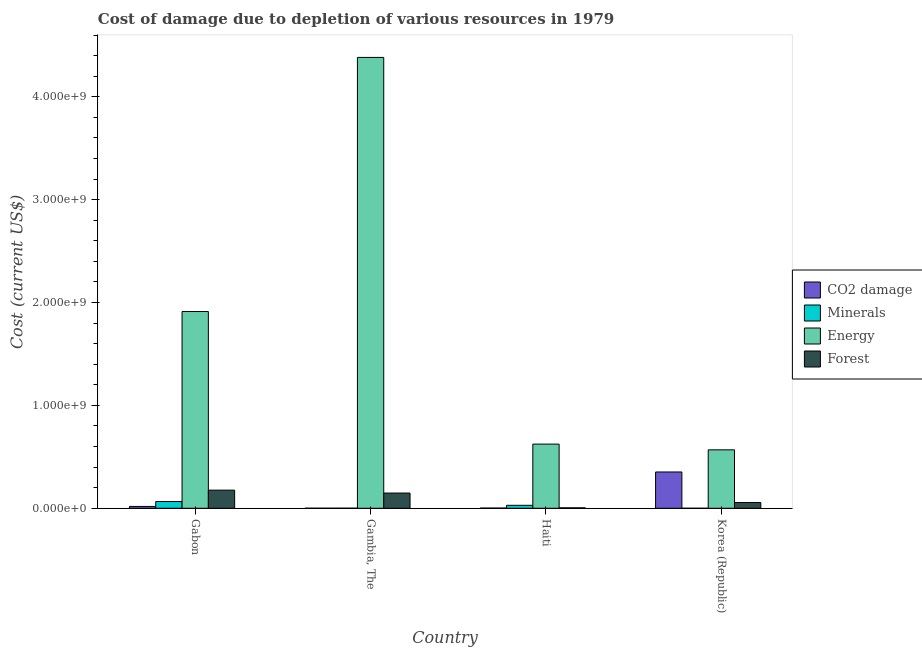How many groups of bars are there?
Your answer should be compact. 4. Are the number of bars per tick equal to the number of legend labels?
Offer a terse response. Yes. Are the number of bars on each tick of the X-axis equal?
Offer a terse response. Yes. How many bars are there on the 1st tick from the left?
Offer a very short reply. 4. How many bars are there on the 3rd tick from the right?
Provide a short and direct response. 4. What is the label of the 3rd group of bars from the left?
Give a very brief answer. Haiti. In how many cases, is the number of bars for a given country not equal to the number of legend labels?
Keep it short and to the point. 0. What is the cost of damage due to depletion of coal in Haiti?
Keep it short and to the point. 2.00e+06. Across all countries, what is the maximum cost of damage due to depletion of energy?
Your answer should be compact. 4.38e+09. Across all countries, what is the minimum cost of damage due to depletion of coal?
Give a very brief answer. 3.89e+05. In which country was the cost of damage due to depletion of coal maximum?
Give a very brief answer. Korea (Republic). In which country was the cost of damage due to depletion of forests minimum?
Provide a short and direct response. Haiti. What is the total cost of damage due to depletion of energy in the graph?
Provide a short and direct response. 7.49e+09. What is the difference between the cost of damage due to depletion of energy in Haiti and that in Korea (Republic)?
Provide a short and direct response. 5.58e+07. What is the difference between the cost of damage due to depletion of energy in Korea (Republic) and the cost of damage due to depletion of minerals in Gabon?
Give a very brief answer. 5.02e+08. What is the average cost of damage due to depletion of coal per country?
Ensure brevity in your answer.  9.33e+07. What is the difference between the cost of damage due to depletion of forests and cost of damage due to depletion of minerals in Gabon?
Offer a very short reply. 1.11e+08. In how many countries, is the cost of damage due to depletion of forests greater than 1600000000 US$?
Your response must be concise. 0. What is the ratio of the cost of damage due to depletion of minerals in Gabon to that in Gambia, The?
Provide a short and direct response. 117.33. Is the cost of damage due to depletion of minerals in Gabon less than that in Gambia, The?
Your response must be concise. No. Is the difference between the cost of damage due to depletion of forests in Gabon and Korea (Republic) greater than the difference between the cost of damage due to depletion of energy in Gabon and Korea (Republic)?
Provide a short and direct response. No. What is the difference between the highest and the second highest cost of damage due to depletion of coal?
Your answer should be very brief. 3.35e+08. What is the difference between the highest and the lowest cost of damage due to depletion of energy?
Provide a succinct answer. 3.81e+09. Is the sum of the cost of damage due to depletion of forests in Gabon and Haiti greater than the maximum cost of damage due to depletion of minerals across all countries?
Offer a very short reply. Yes. What does the 3rd bar from the left in Gabon represents?
Offer a very short reply. Energy. What does the 1st bar from the right in Haiti represents?
Your answer should be compact. Forest. Is it the case that in every country, the sum of the cost of damage due to depletion of coal and cost of damage due to depletion of minerals is greater than the cost of damage due to depletion of energy?
Your answer should be compact. No. What is the difference between two consecutive major ticks on the Y-axis?
Your response must be concise. 1.00e+09. Are the values on the major ticks of Y-axis written in scientific E-notation?
Make the answer very short. Yes. Where does the legend appear in the graph?
Give a very brief answer. Center right. How many legend labels are there?
Your answer should be compact. 4. What is the title of the graph?
Provide a short and direct response. Cost of damage due to depletion of various resources in 1979 . Does "Agriculture" appear as one of the legend labels in the graph?
Keep it short and to the point. No. What is the label or title of the Y-axis?
Keep it short and to the point. Cost (current US$). What is the Cost (current US$) in CO2 damage in Gabon?
Keep it short and to the point. 1.79e+07. What is the Cost (current US$) of Minerals in Gabon?
Ensure brevity in your answer.  6.56e+07. What is the Cost (current US$) of Energy in Gabon?
Offer a very short reply. 1.91e+09. What is the Cost (current US$) of Forest in Gabon?
Keep it short and to the point. 1.76e+08. What is the Cost (current US$) of CO2 damage in Gambia, The?
Make the answer very short. 3.89e+05. What is the Cost (current US$) of Minerals in Gambia, The?
Give a very brief answer. 5.59e+05. What is the Cost (current US$) of Energy in Gambia, The?
Offer a very short reply. 4.38e+09. What is the Cost (current US$) in Forest in Gambia, The?
Give a very brief answer. 1.48e+08. What is the Cost (current US$) of CO2 damage in Haiti?
Provide a succinct answer. 2.00e+06. What is the Cost (current US$) in Minerals in Haiti?
Provide a short and direct response. 2.88e+07. What is the Cost (current US$) in Energy in Haiti?
Provide a short and direct response. 6.24e+08. What is the Cost (current US$) in Forest in Haiti?
Offer a terse response. 4.27e+06. What is the Cost (current US$) of CO2 damage in Korea (Republic)?
Your response must be concise. 3.53e+08. What is the Cost (current US$) of Minerals in Korea (Republic)?
Your answer should be compact. 2.35e+04. What is the Cost (current US$) in Energy in Korea (Republic)?
Your answer should be compact. 5.68e+08. What is the Cost (current US$) in Forest in Korea (Republic)?
Your response must be concise. 5.59e+07. Across all countries, what is the maximum Cost (current US$) in CO2 damage?
Give a very brief answer. 3.53e+08. Across all countries, what is the maximum Cost (current US$) of Minerals?
Give a very brief answer. 6.56e+07. Across all countries, what is the maximum Cost (current US$) of Energy?
Provide a succinct answer. 4.38e+09. Across all countries, what is the maximum Cost (current US$) of Forest?
Your response must be concise. 1.76e+08. Across all countries, what is the minimum Cost (current US$) of CO2 damage?
Your response must be concise. 3.89e+05. Across all countries, what is the minimum Cost (current US$) of Minerals?
Your answer should be very brief. 2.35e+04. Across all countries, what is the minimum Cost (current US$) of Energy?
Offer a very short reply. 5.68e+08. Across all countries, what is the minimum Cost (current US$) in Forest?
Make the answer very short. 4.27e+06. What is the total Cost (current US$) of CO2 damage in the graph?
Your answer should be very brief. 3.73e+08. What is the total Cost (current US$) of Minerals in the graph?
Give a very brief answer. 9.50e+07. What is the total Cost (current US$) in Energy in the graph?
Ensure brevity in your answer.  7.49e+09. What is the total Cost (current US$) of Forest in the graph?
Provide a short and direct response. 3.84e+08. What is the difference between the Cost (current US$) of CO2 damage in Gabon and that in Gambia, The?
Provide a succinct answer. 1.75e+07. What is the difference between the Cost (current US$) of Minerals in Gabon and that in Gambia, The?
Your answer should be compact. 6.51e+07. What is the difference between the Cost (current US$) of Energy in Gabon and that in Gambia, The?
Ensure brevity in your answer.  -2.47e+09. What is the difference between the Cost (current US$) of Forest in Gabon and that in Gambia, The?
Ensure brevity in your answer.  2.82e+07. What is the difference between the Cost (current US$) in CO2 damage in Gabon and that in Haiti?
Provide a short and direct response. 1.59e+07. What is the difference between the Cost (current US$) in Minerals in Gabon and that in Haiti?
Offer a terse response. 3.68e+07. What is the difference between the Cost (current US$) in Energy in Gabon and that in Haiti?
Offer a terse response. 1.29e+09. What is the difference between the Cost (current US$) of Forest in Gabon and that in Haiti?
Make the answer very short. 1.72e+08. What is the difference between the Cost (current US$) in CO2 damage in Gabon and that in Korea (Republic)?
Offer a very short reply. -3.35e+08. What is the difference between the Cost (current US$) in Minerals in Gabon and that in Korea (Republic)?
Your answer should be compact. 6.56e+07. What is the difference between the Cost (current US$) of Energy in Gabon and that in Korea (Republic)?
Provide a succinct answer. 1.34e+09. What is the difference between the Cost (current US$) in Forest in Gabon and that in Korea (Republic)?
Your response must be concise. 1.20e+08. What is the difference between the Cost (current US$) in CO2 damage in Gambia, The and that in Haiti?
Keep it short and to the point. -1.61e+06. What is the difference between the Cost (current US$) of Minerals in Gambia, The and that in Haiti?
Ensure brevity in your answer.  -2.82e+07. What is the difference between the Cost (current US$) of Energy in Gambia, The and that in Haiti?
Provide a short and direct response. 3.76e+09. What is the difference between the Cost (current US$) of Forest in Gambia, The and that in Haiti?
Offer a terse response. 1.44e+08. What is the difference between the Cost (current US$) of CO2 damage in Gambia, The and that in Korea (Republic)?
Your answer should be compact. -3.52e+08. What is the difference between the Cost (current US$) of Minerals in Gambia, The and that in Korea (Republic)?
Offer a terse response. 5.36e+05. What is the difference between the Cost (current US$) of Energy in Gambia, The and that in Korea (Republic)?
Keep it short and to the point. 3.81e+09. What is the difference between the Cost (current US$) of Forest in Gambia, The and that in Korea (Republic)?
Give a very brief answer. 9.21e+07. What is the difference between the Cost (current US$) of CO2 damage in Haiti and that in Korea (Republic)?
Keep it short and to the point. -3.51e+08. What is the difference between the Cost (current US$) in Minerals in Haiti and that in Korea (Republic)?
Provide a succinct answer. 2.88e+07. What is the difference between the Cost (current US$) in Energy in Haiti and that in Korea (Republic)?
Provide a short and direct response. 5.58e+07. What is the difference between the Cost (current US$) in Forest in Haiti and that in Korea (Republic)?
Provide a short and direct response. -5.16e+07. What is the difference between the Cost (current US$) in CO2 damage in Gabon and the Cost (current US$) in Minerals in Gambia, The?
Provide a short and direct response. 1.73e+07. What is the difference between the Cost (current US$) in CO2 damage in Gabon and the Cost (current US$) in Energy in Gambia, The?
Offer a terse response. -4.37e+09. What is the difference between the Cost (current US$) of CO2 damage in Gabon and the Cost (current US$) of Forest in Gambia, The?
Offer a terse response. -1.30e+08. What is the difference between the Cost (current US$) of Minerals in Gabon and the Cost (current US$) of Energy in Gambia, The?
Your answer should be very brief. -4.32e+09. What is the difference between the Cost (current US$) in Minerals in Gabon and the Cost (current US$) in Forest in Gambia, The?
Your response must be concise. -8.24e+07. What is the difference between the Cost (current US$) in Energy in Gabon and the Cost (current US$) in Forest in Gambia, The?
Make the answer very short. 1.76e+09. What is the difference between the Cost (current US$) in CO2 damage in Gabon and the Cost (current US$) in Minerals in Haiti?
Provide a short and direct response. -1.09e+07. What is the difference between the Cost (current US$) of CO2 damage in Gabon and the Cost (current US$) of Energy in Haiti?
Provide a short and direct response. -6.06e+08. What is the difference between the Cost (current US$) in CO2 damage in Gabon and the Cost (current US$) in Forest in Haiti?
Ensure brevity in your answer.  1.36e+07. What is the difference between the Cost (current US$) in Minerals in Gabon and the Cost (current US$) in Energy in Haiti?
Offer a terse response. -5.58e+08. What is the difference between the Cost (current US$) of Minerals in Gabon and the Cost (current US$) of Forest in Haiti?
Ensure brevity in your answer.  6.13e+07. What is the difference between the Cost (current US$) of Energy in Gabon and the Cost (current US$) of Forest in Haiti?
Provide a short and direct response. 1.91e+09. What is the difference between the Cost (current US$) in CO2 damage in Gabon and the Cost (current US$) in Minerals in Korea (Republic)?
Ensure brevity in your answer.  1.79e+07. What is the difference between the Cost (current US$) of CO2 damage in Gabon and the Cost (current US$) of Energy in Korea (Republic)?
Your response must be concise. -5.50e+08. What is the difference between the Cost (current US$) of CO2 damage in Gabon and the Cost (current US$) of Forest in Korea (Republic)?
Offer a very short reply. -3.80e+07. What is the difference between the Cost (current US$) in Minerals in Gabon and the Cost (current US$) in Energy in Korea (Republic)?
Provide a succinct answer. -5.02e+08. What is the difference between the Cost (current US$) of Minerals in Gabon and the Cost (current US$) of Forest in Korea (Republic)?
Provide a short and direct response. 9.70e+06. What is the difference between the Cost (current US$) in Energy in Gabon and the Cost (current US$) in Forest in Korea (Republic)?
Keep it short and to the point. 1.86e+09. What is the difference between the Cost (current US$) in CO2 damage in Gambia, The and the Cost (current US$) in Minerals in Haiti?
Offer a very short reply. -2.84e+07. What is the difference between the Cost (current US$) in CO2 damage in Gambia, The and the Cost (current US$) in Energy in Haiti?
Ensure brevity in your answer.  -6.23e+08. What is the difference between the Cost (current US$) of CO2 damage in Gambia, The and the Cost (current US$) of Forest in Haiti?
Your answer should be very brief. -3.89e+06. What is the difference between the Cost (current US$) in Minerals in Gambia, The and the Cost (current US$) in Energy in Haiti?
Ensure brevity in your answer.  -6.23e+08. What is the difference between the Cost (current US$) of Minerals in Gambia, The and the Cost (current US$) of Forest in Haiti?
Provide a short and direct response. -3.71e+06. What is the difference between the Cost (current US$) of Energy in Gambia, The and the Cost (current US$) of Forest in Haiti?
Provide a succinct answer. 4.38e+09. What is the difference between the Cost (current US$) of CO2 damage in Gambia, The and the Cost (current US$) of Minerals in Korea (Republic)?
Your response must be concise. 3.65e+05. What is the difference between the Cost (current US$) of CO2 damage in Gambia, The and the Cost (current US$) of Energy in Korea (Republic)?
Offer a very short reply. -5.68e+08. What is the difference between the Cost (current US$) of CO2 damage in Gambia, The and the Cost (current US$) of Forest in Korea (Republic)?
Your answer should be compact. -5.55e+07. What is the difference between the Cost (current US$) of Minerals in Gambia, The and the Cost (current US$) of Energy in Korea (Republic)?
Provide a short and direct response. -5.68e+08. What is the difference between the Cost (current US$) in Minerals in Gambia, The and the Cost (current US$) in Forest in Korea (Republic)?
Make the answer very short. -5.54e+07. What is the difference between the Cost (current US$) in Energy in Gambia, The and the Cost (current US$) in Forest in Korea (Republic)?
Provide a short and direct response. 4.33e+09. What is the difference between the Cost (current US$) of CO2 damage in Haiti and the Cost (current US$) of Minerals in Korea (Republic)?
Provide a succinct answer. 1.98e+06. What is the difference between the Cost (current US$) in CO2 damage in Haiti and the Cost (current US$) in Energy in Korea (Republic)?
Your answer should be compact. -5.66e+08. What is the difference between the Cost (current US$) in CO2 damage in Haiti and the Cost (current US$) in Forest in Korea (Republic)?
Provide a short and direct response. -5.39e+07. What is the difference between the Cost (current US$) in Minerals in Haiti and the Cost (current US$) in Energy in Korea (Republic)?
Make the answer very short. -5.39e+08. What is the difference between the Cost (current US$) of Minerals in Haiti and the Cost (current US$) of Forest in Korea (Republic)?
Offer a very short reply. -2.71e+07. What is the difference between the Cost (current US$) of Energy in Haiti and the Cost (current US$) of Forest in Korea (Republic)?
Offer a very short reply. 5.68e+08. What is the average Cost (current US$) of CO2 damage per country?
Offer a terse response. 9.33e+07. What is the average Cost (current US$) in Minerals per country?
Ensure brevity in your answer.  2.37e+07. What is the average Cost (current US$) of Energy per country?
Give a very brief answer. 1.87e+09. What is the average Cost (current US$) in Forest per country?
Provide a succinct answer. 9.61e+07. What is the difference between the Cost (current US$) in CO2 damage and Cost (current US$) in Minerals in Gabon?
Give a very brief answer. -4.77e+07. What is the difference between the Cost (current US$) of CO2 damage and Cost (current US$) of Energy in Gabon?
Keep it short and to the point. -1.89e+09. What is the difference between the Cost (current US$) in CO2 damage and Cost (current US$) in Forest in Gabon?
Make the answer very short. -1.58e+08. What is the difference between the Cost (current US$) in Minerals and Cost (current US$) in Energy in Gabon?
Make the answer very short. -1.85e+09. What is the difference between the Cost (current US$) of Minerals and Cost (current US$) of Forest in Gabon?
Offer a terse response. -1.11e+08. What is the difference between the Cost (current US$) of Energy and Cost (current US$) of Forest in Gabon?
Ensure brevity in your answer.  1.74e+09. What is the difference between the Cost (current US$) in CO2 damage and Cost (current US$) in Minerals in Gambia, The?
Offer a very short reply. -1.71e+05. What is the difference between the Cost (current US$) of CO2 damage and Cost (current US$) of Energy in Gambia, The?
Your response must be concise. -4.38e+09. What is the difference between the Cost (current US$) of CO2 damage and Cost (current US$) of Forest in Gambia, The?
Keep it short and to the point. -1.48e+08. What is the difference between the Cost (current US$) in Minerals and Cost (current US$) in Energy in Gambia, The?
Your answer should be very brief. -4.38e+09. What is the difference between the Cost (current US$) in Minerals and Cost (current US$) in Forest in Gambia, The?
Your answer should be very brief. -1.47e+08. What is the difference between the Cost (current US$) of Energy and Cost (current US$) of Forest in Gambia, The?
Your answer should be very brief. 4.23e+09. What is the difference between the Cost (current US$) of CO2 damage and Cost (current US$) of Minerals in Haiti?
Provide a short and direct response. -2.68e+07. What is the difference between the Cost (current US$) in CO2 damage and Cost (current US$) in Energy in Haiti?
Give a very brief answer. -6.22e+08. What is the difference between the Cost (current US$) of CO2 damage and Cost (current US$) of Forest in Haiti?
Make the answer very short. -2.27e+06. What is the difference between the Cost (current US$) of Minerals and Cost (current US$) of Energy in Haiti?
Offer a terse response. -5.95e+08. What is the difference between the Cost (current US$) in Minerals and Cost (current US$) in Forest in Haiti?
Your answer should be compact. 2.45e+07. What is the difference between the Cost (current US$) of Energy and Cost (current US$) of Forest in Haiti?
Your answer should be compact. 6.20e+08. What is the difference between the Cost (current US$) of CO2 damage and Cost (current US$) of Minerals in Korea (Republic)?
Give a very brief answer. 3.53e+08. What is the difference between the Cost (current US$) in CO2 damage and Cost (current US$) in Energy in Korea (Republic)?
Your answer should be compact. -2.15e+08. What is the difference between the Cost (current US$) of CO2 damage and Cost (current US$) of Forest in Korea (Republic)?
Provide a succinct answer. 2.97e+08. What is the difference between the Cost (current US$) of Minerals and Cost (current US$) of Energy in Korea (Republic)?
Your answer should be compact. -5.68e+08. What is the difference between the Cost (current US$) in Minerals and Cost (current US$) in Forest in Korea (Republic)?
Offer a very short reply. -5.59e+07. What is the difference between the Cost (current US$) in Energy and Cost (current US$) in Forest in Korea (Republic)?
Give a very brief answer. 5.12e+08. What is the ratio of the Cost (current US$) of CO2 damage in Gabon to that in Gambia, The?
Provide a short and direct response. 46.05. What is the ratio of the Cost (current US$) of Minerals in Gabon to that in Gambia, The?
Make the answer very short. 117.33. What is the ratio of the Cost (current US$) of Energy in Gabon to that in Gambia, The?
Keep it short and to the point. 0.44. What is the ratio of the Cost (current US$) of Forest in Gabon to that in Gambia, The?
Provide a short and direct response. 1.19. What is the ratio of the Cost (current US$) in CO2 damage in Gabon to that in Haiti?
Keep it short and to the point. 8.94. What is the ratio of the Cost (current US$) of Minerals in Gabon to that in Haiti?
Make the answer very short. 2.28. What is the ratio of the Cost (current US$) of Energy in Gabon to that in Haiti?
Provide a short and direct response. 3.07. What is the ratio of the Cost (current US$) in Forest in Gabon to that in Haiti?
Offer a terse response. 41.24. What is the ratio of the Cost (current US$) of CO2 damage in Gabon to that in Korea (Republic)?
Provide a succinct answer. 0.05. What is the ratio of the Cost (current US$) of Minerals in Gabon to that in Korea (Republic)?
Offer a very short reply. 2797.55. What is the ratio of the Cost (current US$) of Energy in Gabon to that in Korea (Republic)?
Provide a short and direct response. 3.37. What is the ratio of the Cost (current US$) in Forest in Gabon to that in Korea (Republic)?
Your answer should be compact. 3.15. What is the ratio of the Cost (current US$) of CO2 damage in Gambia, The to that in Haiti?
Ensure brevity in your answer.  0.19. What is the ratio of the Cost (current US$) in Minerals in Gambia, The to that in Haiti?
Provide a succinct answer. 0.02. What is the ratio of the Cost (current US$) of Energy in Gambia, The to that in Haiti?
Provide a succinct answer. 7.03. What is the ratio of the Cost (current US$) of Forest in Gambia, The to that in Haiti?
Provide a succinct answer. 34.63. What is the ratio of the Cost (current US$) in CO2 damage in Gambia, The to that in Korea (Republic)?
Offer a terse response. 0. What is the ratio of the Cost (current US$) in Minerals in Gambia, The to that in Korea (Republic)?
Provide a succinct answer. 23.84. What is the ratio of the Cost (current US$) of Energy in Gambia, The to that in Korea (Republic)?
Offer a terse response. 7.72. What is the ratio of the Cost (current US$) of Forest in Gambia, The to that in Korea (Republic)?
Ensure brevity in your answer.  2.65. What is the ratio of the Cost (current US$) in CO2 damage in Haiti to that in Korea (Republic)?
Offer a very short reply. 0.01. What is the ratio of the Cost (current US$) of Minerals in Haiti to that in Korea (Republic)?
Your answer should be very brief. 1227.25. What is the ratio of the Cost (current US$) of Energy in Haiti to that in Korea (Republic)?
Ensure brevity in your answer.  1.1. What is the ratio of the Cost (current US$) in Forest in Haiti to that in Korea (Republic)?
Make the answer very short. 0.08. What is the difference between the highest and the second highest Cost (current US$) in CO2 damage?
Offer a terse response. 3.35e+08. What is the difference between the highest and the second highest Cost (current US$) of Minerals?
Your response must be concise. 3.68e+07. What is the difference between the highest and the second highest Cost (current US$) of Energy?
Make the answer very short. 2.47e+09. What is the difference between the highest and the second highest Cost (current US$) of Forest?
Offer a very short reply. 2.82e+07. What is the difference between the highest and the lowest Cost (current US$) of CO2 damage?
Give a very brief answer. 3.52e+08. What is the difference between the highest and the lowest Cost (current US$) in Minerals?
Offer a terse response. 6.56e+07. What is the difference between the highest and the lowest Cost (current US$) in Energy?
Make the answer very short. 3.81e+09. What is the difference between the highest and the lowest Cost (current US$) of Forest?
Give a very brief answer. 1.72e+08. 